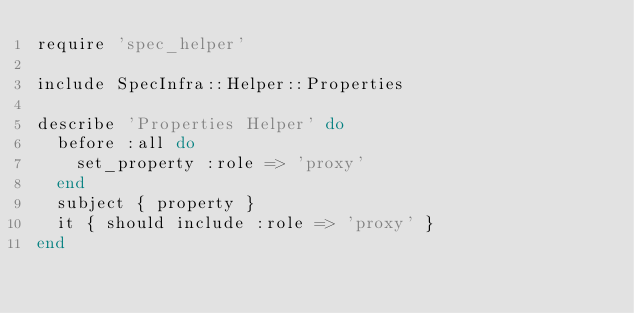<code> <loc_0><loc_0><loc_500><loc_500><_Ruby_>require 'spec_helper'

include SpecInfra::Helper::Properties

describe 'Properties Helper' do
  before :all do
    set_property :role => 'proxy'
  end
  subject { property }
  it { should include :role => 'proxy' }
end
</code> 